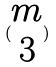Convert formula to latex. <formula><loc_0><loc_0><loc_500><loc_500>( \begin{matrix} m \\ 3 \end{matrix} )</formula> 